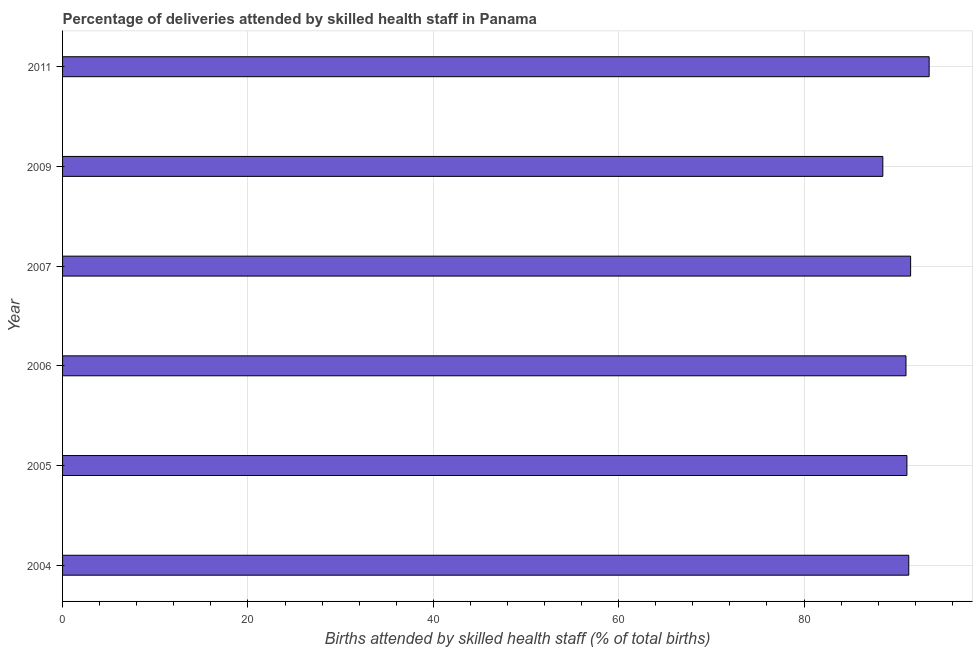Does the graph contain any zero values?
Your answer should be very brief. No. What is the title of the graph?
Ensure brevity in your answer.  Percentage of deliveries attended by skilled health staff in Panama. What is the label or title of the X-axis?
Ensure brevity in your answer.  Births attended by skilled health staff (% of total births). What is the number of births attended by skilled health staff in 2007?
Give a very brief answer. 91.5. Across all years, what is the maximum number of births attended by skilled health staff?
Ensure brevity in your answer.  93.5. Across all years, what is the minimum number of births attended by skilled health staff?
Provide a short and direct response. 88.5. What is the sum of the number of births attended by skilled health staff?
Provide a short and direct response. 546.9. What is the average number of births attended by skilled health staff per year?
Your answer should be compact. 91.15. What is the median number of births attended by skilled health staff?
Keep it short and to the point. 91.2. In how many years, is the number of births attended by skilled health staff greater than 68 %?
Your response must be concise. 6. Do a majority of the years between 2006 and 2007 (inclusive) have number of births attended by skilled health staff greater than 64 %?
Keep it short and to the point. Yes. Is the difference between the number of births attended by skilled health staff in 2006 and 2009 greater than the difference between any two years?
Make the answer very short. No. What is the difference between the highest and the second highest number of births attended by skilled health staff?
Keep it short and to the point. 2. Is the sum of the number of births attended by skilled health staff in 2006 and 2011 greater than the maximum number of births attended by skilled health staff across all years?
Provide a short and direct response. Yes. In how many years, is the number of births attended by skilled health staff greater than the average number of births attended by skilled health staff taken over all years?
Make the answer very short. 3. How many bars are there?
Make the answer very short. 6. Are the values on the major ticks of X-axis written in scientific E-notation?
Offer a very short reply. No. What is the Births attended by skilled health staff (% of total births) in 2004?
Make the answer very short. 91.3. What is the Births attended by skilled health staff (% of total births) in 2005?
Make the answer very short. 91.1. What is the Births attended by skilled health staff (% of total births) in 2006?
Your answer should be compact. 91. What is the Births attended by skilled health staff (% of total births) in 2007?
Make the answer very short. 91.5. What is the Births attended by skilled health staff (% of total births) of 2009?
Your response must be concise. 88.5. What is the Births attended by skilled health staff (% of total births) in 2011?
Make the answer very short. 93.5. What is the difference between the Births attended by skilled health staff (% of total births) in 2004 and 2005?
Make the answer very short. 0.2. What is the difference between the Births attended by skilled health staff (% of total births) in 2004 and 2011?
Ensure brevity in your answer.  -2.2. What is the difference between the Births attended by skilled health staff (% of total births) in 2005 and 2007?
Give a very brief answer. -0.4. What is the difference between the Births attended by skilled health staff (% of total births) in 2006 and 2007?
Make the answer very short. -0.5. What is the difference between the Births attended by skilled health staff (% of total births) in 2006 and 2009?
Keep it short and to the point. 2.5. What is the difference between the Births attended by skilled health staff (% of total births) in 2007 and 2009?
Ensure brevity in your answer.  3. What is the difference between the Births attended by skilled health staff (% of total births) in 2009 and 2011?
Your answer should be compact. -5. What is the ratio of the Births attended by skilled health staff (% of total births) in 2004 to that in 2005?
Keep it short and to the point. 1. What is the ratio of the Births attended by skilled health staff (% of total births) in 2004 to that in 2009?
Give a very brief answer. 1.03. What is the ratio of the Births attended by skilled health staff (% of total births) in 2004 to that in 2011?
Provide a short and direct response. 0.98. What is the ratio of the Births attended by skilled health staff (% of total births) in 2005 to that in 2007?
Your response must be concise. 1. What is the ratio of the Births attended by skilled health staff (% of total births) in 2005 to that in 2009?
Give a very brief answer. 1.03. What is the ratio of the Births attended by skilled health staff (% of total births) in 2005 to that in 2011?
Your answer should be compact. 0.97. What is the ratio of the Births attended by skilled health staff (% of total births) in 2006 to that in 2009?
Keep it short and to the point. 1.03. What is the ratio of the Births attended by skilled health staff (% of total births) in 2007 to that in 2009?
Offer a terse response. 1.03. What is the ratio of the Births attended by skilled health staff (% of total births) in 2009 to that in 2011?
Offer a terse response. 0.95. 